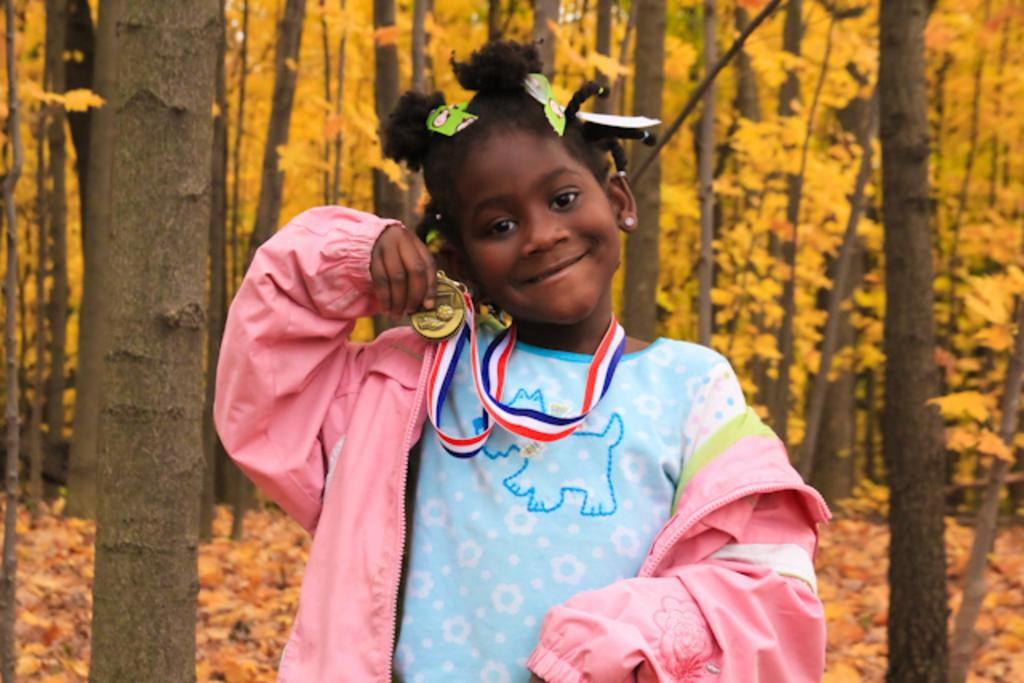Who is the main subject in the image? There is a girl in the image. What is the girl wearing? The girl is wearing a jacket. What is the girl holding in the image? The girl is holding a medal. What is the girl's facial expression? The girl is smiling. What can be seen in the background of the image? There are trees in the background of the image. Can you see any tomatoes growing on the trees in the background? There are no tomatoes visible in the image, and the trees in the background do not appear to be fruit-bearing trees. 